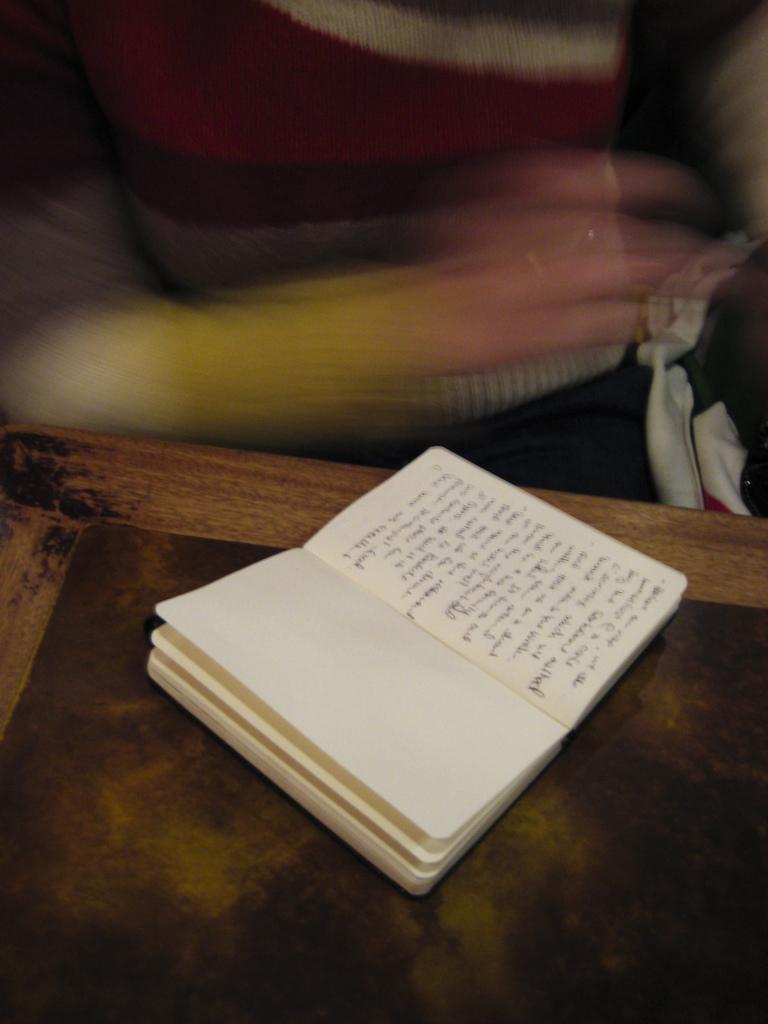Describe this image in one or two sentences. Here in this picture we can see a book with something written on the paper present on the table and behind that we can see a person in blurry manner. 